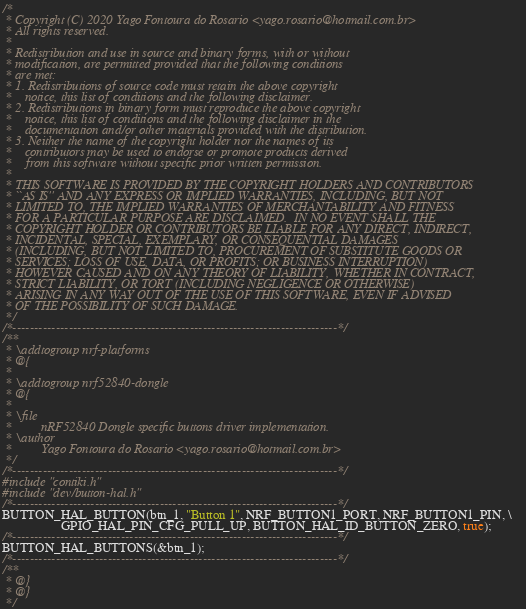<code> <loc_0><loc_0><loc_500><loc_500><_C_>/*
 * Copyright (C) 2020 Yago Fontoura do Rosario <yago.rosario@hotmail.com.br>
 * All rights reserved.
 *
 * Redistribution and use in source and binary forms, with or without
 * modification, are permitted provided that the following conditions
 * are met:
 * 1. Redistributions of source code must retain the above copyright
 *    notice, this list of conditions and the following disclaimer.
 * 2. Redistributions in binary form must reproduce the above copyright
 *    notice, this list of conditions and the following disclaimer in the
 *    documentation and/or other materials provided with the distribution.
 * 3. Neither the name of the copyright holder nor the names of its
 *    contributors may be used to endorse or promote products derived
 *    from this software without specific prior written permission.
 *
 * THIS SOFTWARE IS PROVIDED BY THE COPYRIGHT HOLDERS AND CONTRIBUTORS
 * ``AS IS'' AND ANY EXPRESS OR IMPLIED WARRANTIES, INCLUDING, BUT NOT
 * LIMITED TO, THE IMPLIED WARRANTIES OF MERCHANTABILITY AND FITNESS
 * FOR A PARTICULAR PURPOSE ARE DISCLAIMED.  IN NO EVENT SHALL THE
 * COPYRIGHT HOLDER OR CONTRIBUTORS BE LIABLE FOR ANY DIRECT, INDIRECT,
 * INCIDENTAL, SPECIAL, EXEMPLARY, OR CONSEQUENTIAL DAMAGES
 * (INCLUDING, BUT NOT LIMITED TO, PROCUREMENT OF SUBSTITUTE GOODS OR
 * SERVICES; LOSS OF USE, DATA, OR PROFITS; OR BUSINESS INTERRUPTION)
 * HOWEVER CAUSED AND ON ANY THEORY OF LIABILITY, WHETHER IN CONTRACT,
 * STRICT LIABILITY, OR TORT (INCLUDING NEGLIGENCE OR OTHERWISE)
 * ARISING IN ANY WAY OUT OF THE USE OF THIS SOFTWARE, EVEN IF ADVISED
 * OF THE POSSIBILITY OF SUCH DAMAGE.
 */
/*---------------------------------------------------------------------------*/
/**
 * \addtogroup nrf-platforms
 * @{
 *
 * \addtogroup nrf52840-dongle
 * @{
 *
 * \file
 *         nRF52840 Dongle specific buttons driver implementation.
 * \author
 *         Yago Fontoura do Rosario <yago.rosario@hotmail.com.br>
 */
/*---------------------------------------------------------------------------*/
#include "contiki.h"
#include "dev/button-hal.h"
/*---------------------------------------------------------------------------*/
BUTTON_HAL_BUTTON(btn_1, "Button 1", NRF_BUTTON1_PORT, NRF_BUTTON1_PIN, \
                  GPIO_HAL_PIN_CFG_PULL_UP, BUTTON_HAL_ID_BUTTON_ZERO, true);
/*---------------------------------------------------------------------------*/
BUTTON_HAL_BUTTONS(&btn_1);
/*---------------------------------------------------------------------------*/
/** 
 * @} 
 * @} 
 */
</code> 